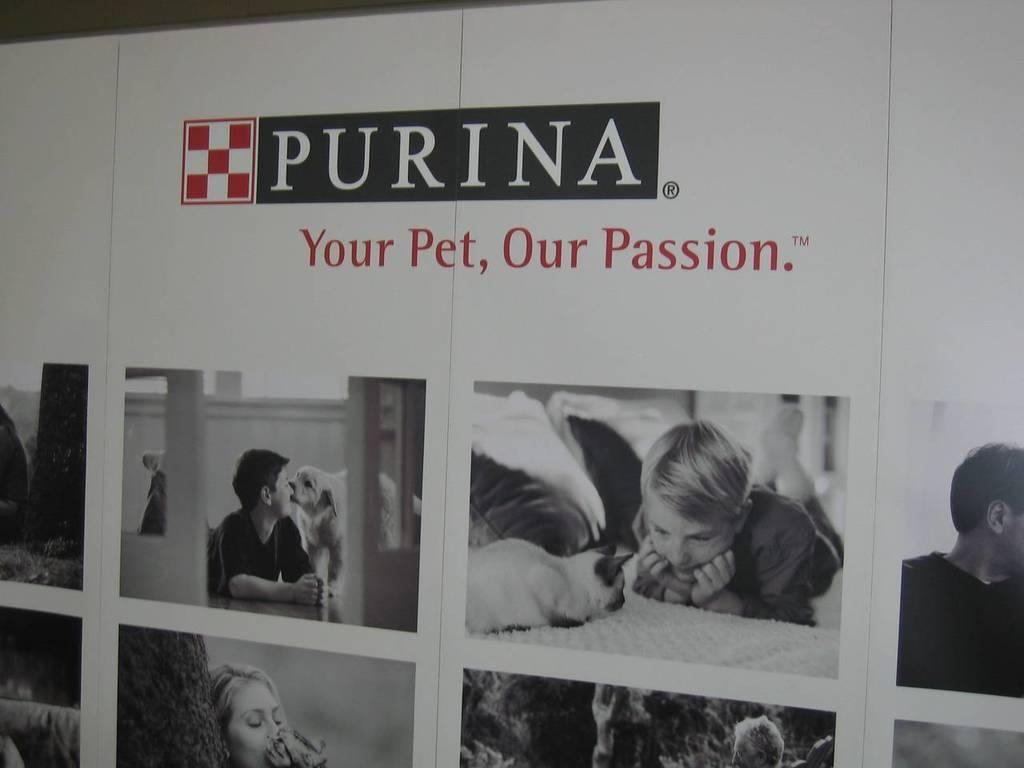What is featured on the poster in the image? The poster contains a collage of many images. What is the boy doing in the image? The boy is lying on the bed in the image. What animal is present in the image? There is a cat in front of the boy in the image. Can you describe the position of the person in the image? There is a person lying in the image. What other animal is present in the image? There is a dog beside the person in the image. What type of spade is being used to dig a hole in the image? There is no spade or hole present in the image. What angle is the poster hanging on the wall in the image? The poster is not hanging on a wall in the image; it is likely on a flat surface. What degree of difficulty is the person attempting in the image? The image does not depict any activity that would have a degree of difficulty. 